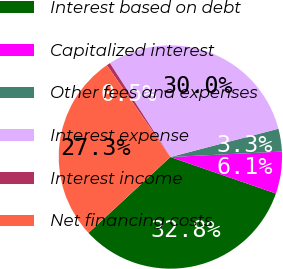Convert chart to OTSL. <chart><loc_0><loc_0><loc_500><loc_500><pie_chart><fcel>Interest based on debt<fcel>Capitalized interest<fcel>Other fees and expenses<fcel>Interest expense<fcel>Interest income<fcel>Net financing costs<nl><fcel>32.82%<fcel>6.07%<fcel>3.3%<fcel>30.04%<fcel>0.52%<fcel>27.26%<nl></chart> 